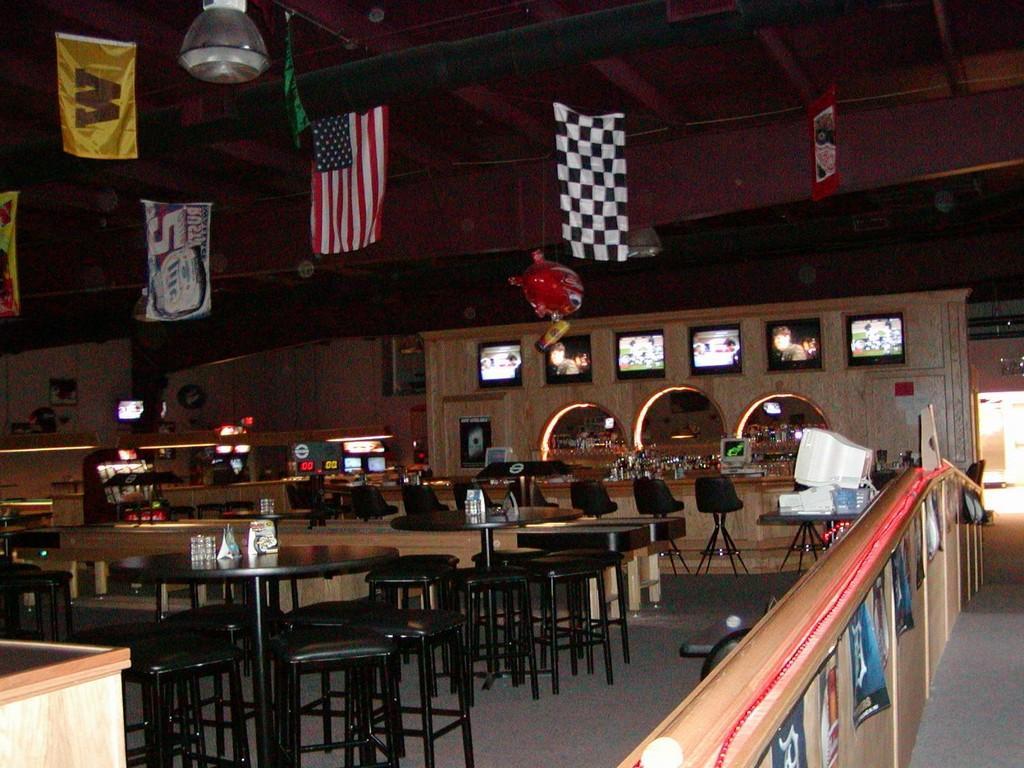Can you describe this image briefly? In this picture we can see a computer on a table. There are a few objects on the tables. We can see a few flags and a light on top. There are a few chairs. We can see a few lights in the background. 